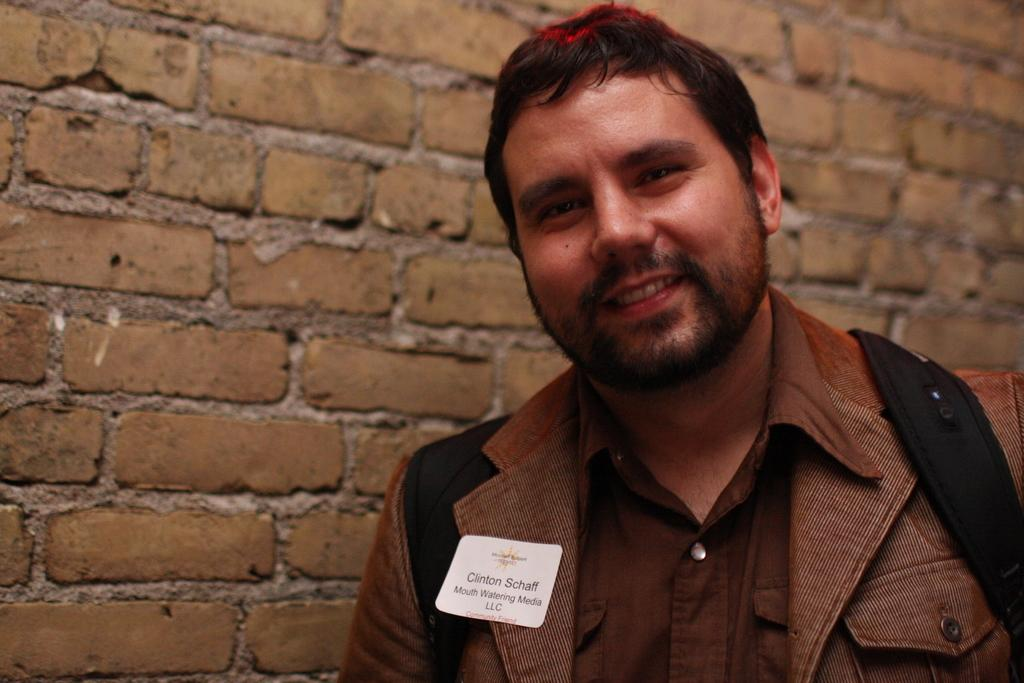Who or what is present in the image? There is a person in the image. What is the person wearing? The person is wearing a brown color dress. Are there any additional details about the dress? Yes, there is a white color badge on the dress. What can be seen in the background of the image? There is a brown color brick wall in the background of the image. What type of heart-shaped object can be seen in the image? There is no heart-shaped object present in the image. 